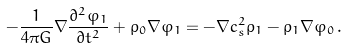<formula> <loc_0><loc_0><loc_500><loc_500>- \frac { 1 } { 4 \pi G } \nabla \frac { \partial ^ { 2 } \varphi _ { 1 } } { \partial t ^ { 2 } } + \rho _ { 0 } \nabla \varphi _ { 1 } = - \nabla c _ { s } ^ { 2 } \rho _ { 1 } - \rho _ { 1 } \nabla \varphi _ { 0 } \, .</formula> 